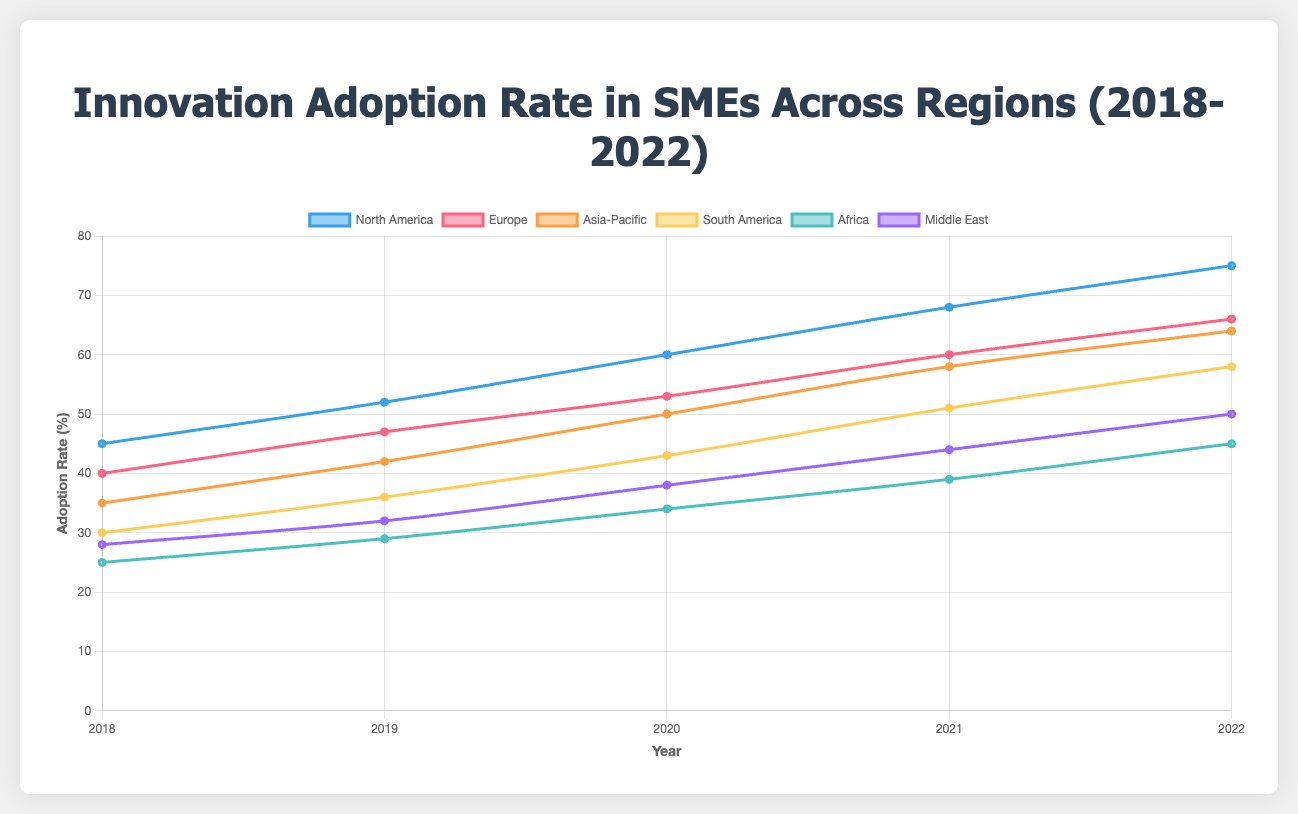What's the trend of the innovation adoption rate in North America from 2018 to 2022? The adoption rate in North America shows a continuous increase from 45% in 2018 to 75% in 2022. This steady rise indicates a positive trend in innovation adoption among SMEs in North America.
Answer: Continuous increase Which region had the highest adoption rate in 2022? In 2022, North America had the highest adoption rate at 75%, followed by Europe at 66%, indicating that North American SMEs are leading in innovation adoption.
Answer: North America Compare the adoption rates of Europe and Asia-Pacific in 2020. Which region had a higher adoption rate and by how much? In 2020, Europe's adoption rate was 53%, while Asia-Pacific's was 50%. Europe had a higher adoption rate by 3 percentage points.
Answer: Europe by 3% Calculate the average adoption rate for South America across the five years. The adoption rates for South America from 2018 to 2022 are 30%, 36%, 43%, 51%, and 58%. Summing these values gives (30+36+43+51+58) = 218. Dividing by 5 gives an average of 43.6%.
Answer: 43.6% Which region had the lowest adoption rate in 2018, and what was the rate? In 2018, Africa had the lowest adoption rate at 25%.
Answer: Africa, 25% What is the difference in adoption rates between the Middle East and Africa in 2022? In 2022, the Middle East had an adoption rate of 50%, and Africa had 45%. The difference is 50% - 45% = 5%.
Answer: 5% How did the adoption rate in Africa change from 2018 to 2022? The adoption rate in Africa increased from 25% in 2018 to 45% in 2022. This is a change of 45% - 25% = 20%.
Answer: Increased by 20% What year did North America surpass the 60% adoption rate? North America surpassed the 60% adoption rate in 2020, with an adoption rate of 60%.
Answer: 2020 Compare the adoption rate growth over the five years between North America and South America. Which region experienced a larger increase? North America's adoption rate increased from 45% to 75% (an increase of 30%), while South America's increased from 30% to 58% (an increase of 28%). North America experienced a larger increase by 2%.
Answer: North America by 2% Which two regions had the closest adoption rates in 2019, and what were their rates? In 2019, Europe and Asia-Pacific had the closest adoption rates at 47% and 42%, respectively. The difference between their rates is 5 percentage points.
Answer: Europe and Asia-Pacific, 47% and 42% 